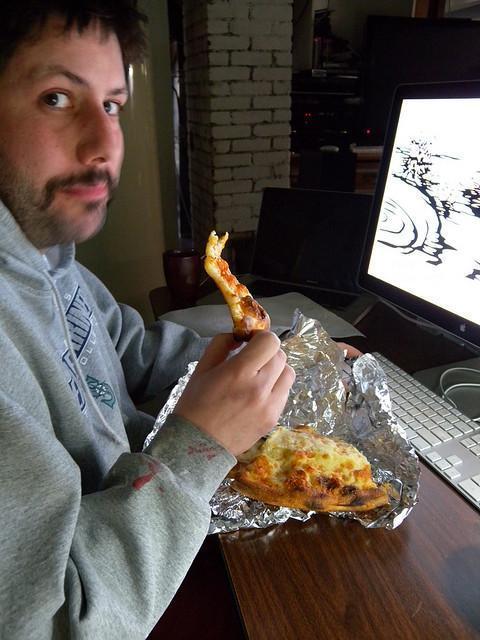How many pizzas are in the photo?
Give a very brief answer. 2. How many birds are there?
Give a very brief answer. 0. 